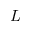Convert formula to latex. <formula><loc_0><loc_0><loc_500><loc_500>L</formula> 